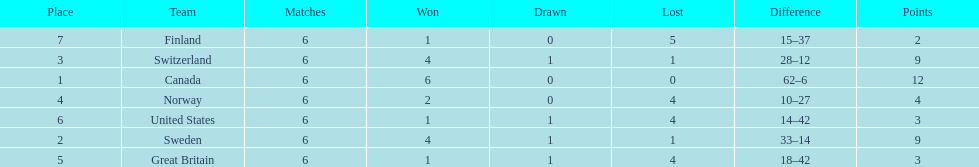Which team won more matches, finland or norway? Norway. 